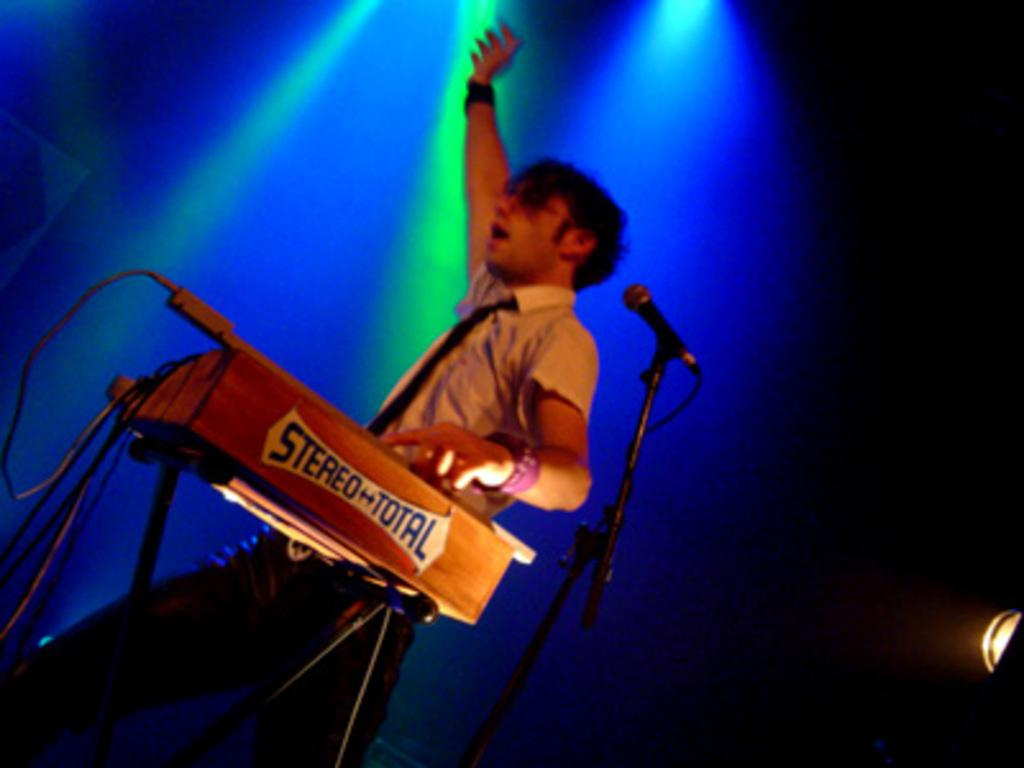What is the man in the image doing? The man is playing a musical instrument in the image. What object is present that might be used for amplifying the man's voice? There is a microphone in the image. What can be seen attached to the ceiling in the image? Lights are attached to the ceiling in the image. How does the man's breath affect the sound of the musical instrument in the image? The image does not provide information about the man's breath or how it might affect the sound of the musical instrument. 